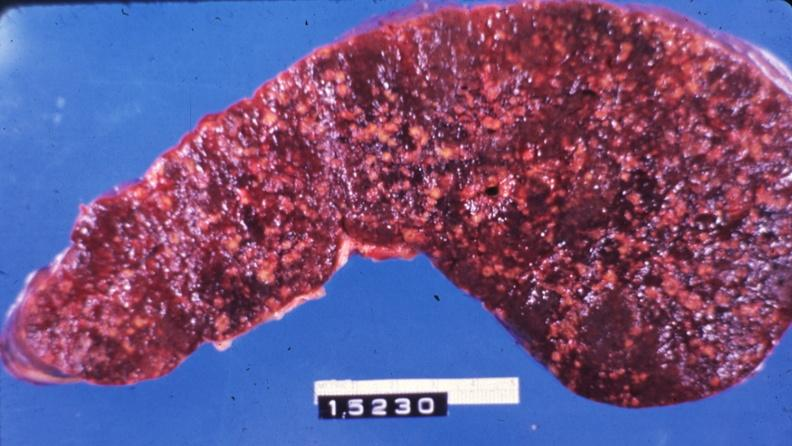s hematologic present?
Answer the question using a single word or phrase. Yes 